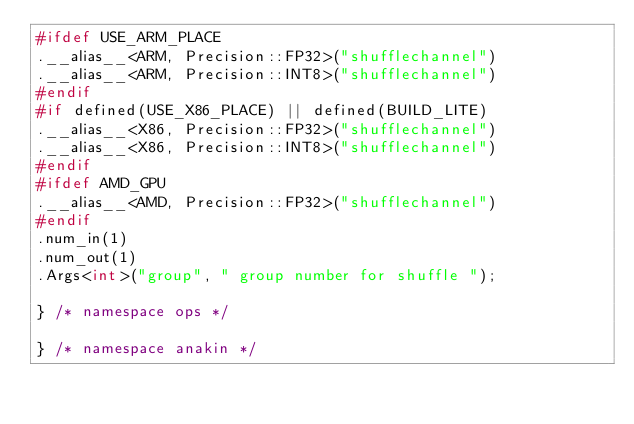Convert code to text. <code><loc_0><loc_0><loc_500><loc_500><_C++_>#ifdef USE_ARM_PLACE
.__alias__<ARM, Precision::FP32>("shufflechannel")
.__alias__<ARM, Precision::INT8>("shufflechannel")
#endif
#if defined(USE_X86_PLACE) || defined(BUILD_LITE)
.__alias__<X86, Precision::FP32>("shufflechannel")
.__alias__<X86, Precision::INT8>("shufflechannel")
#endif
#ifdef AMD_GPU
.__alias__<AMD, Precision::FP32>("shufflechannel")
#endif
.num_in(1)
.num_out(1)
.Args<int>("group", " group number for shuffle ");

} /* namespace ops */

} /* namespace anakin */


</code> 